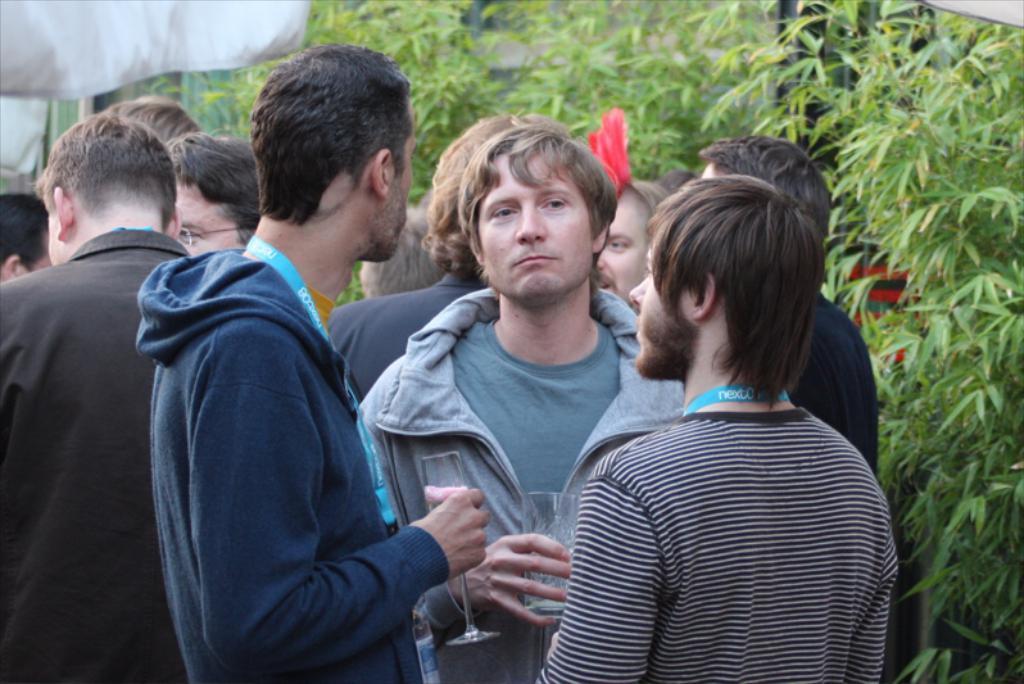Describe this image in one or two sentences. In this image, we can see persons wearing clothes. There are branches at the top and on the right side of the image. There are two persons in the middle of the image holding glasses with their hands. 